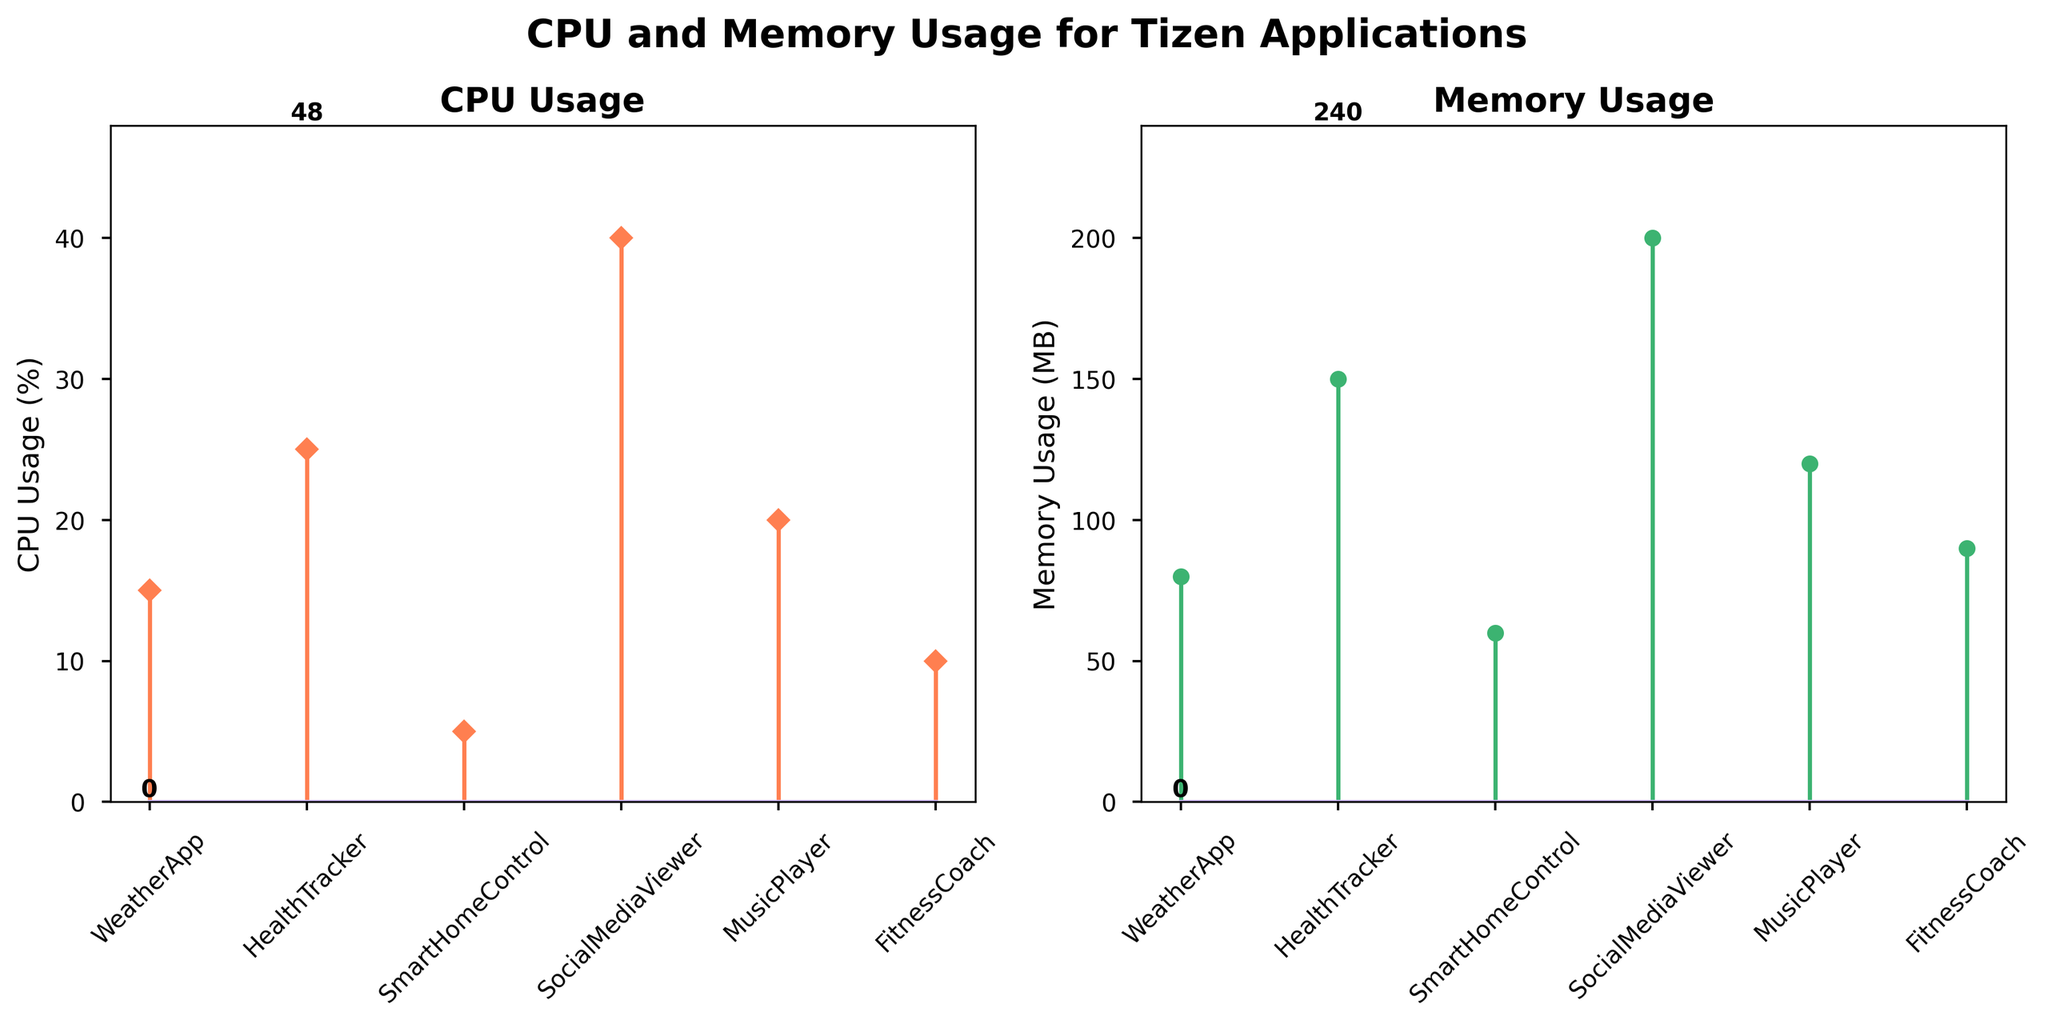What is the title of this figure? The title is situated at the top of the figure, prominently displayed to indicate the subject of the plots. It reads "CPU and Memory Usage for Tizen Applications".
Answer: CPU and Memory Usage for Tizen Applications How many applications are included in the figure? The figure has labeled markers along the x-axis representing each application. By counting these labels, we see six different Tizen applications.
Answer: 6 Which application has the highest CPU usage? The stem plot on the left shows CPU usage in percentages for each application. The tallest stem corresponds to the "SocialMediaViewer", indicating it has the highest CPU usage.
Answer: SocialMediaViewer Which two applications have the lowest Memory usage? The stem plot on the right side displays memory usage for each application. "SmartHomeControl" and "WeatherApp" have the two lowest stems, meaning they have the lowest memory usage.
Answer: SmartHomeControl and WeatherApp What is the difference in CPU usage between the "HealthTracker" and "MusicPlayer"? Refer the CPU usage stem plot: HealthTracker uses 25% CPU and MusicPlayer uses 20%. The difference is calculated as 25% - 20%.
Answer: 5% What is the average Memory usage of all applications? The average memory usage is calculated by summing all memory values and dividing by the number of applications: (80 + 150 + 60 + 200 + 120 + 90) / 6. This sums to 700 MB, and dividing by 6 gives approximately 116.67 MB.
Answer: 116.67 MB Which application uses less CPU but more Memory than "FitnessCoach"? From the stem plots, "FitnessCoach" uses 10% CPU and 90 MB Memory. "SmartHomeControl" uses 5% CPU (less) but only 60 MB Memory (not more). "WeatherApp" uses 15% CPU (more) and only 80 MB Memory (not more). Both conditions are matched by no applications.
Answer: None Among all the applications, which shows the most balanced use of CPU and Memory? By glancing at both stem plots, the most balanced application would have similar heights for both CPU and Memory usages. "MusicPlayer" uses 20% CPU and 120 MB Memory, which seem closest in balance.
Answer: MusicPlayer Compare "WeatherApp" and "HealthTracker" – which one is more resource-efficient overall? "WeatherApp" uses 15% CPU and 80 MB Memory. "HealthTracker" uses 25% CPU and 150 MB Memory. Both CPU and Memory usage are lower for "WeatherApp", making it more resource-efficient overall.
Answer: WeatherApp 